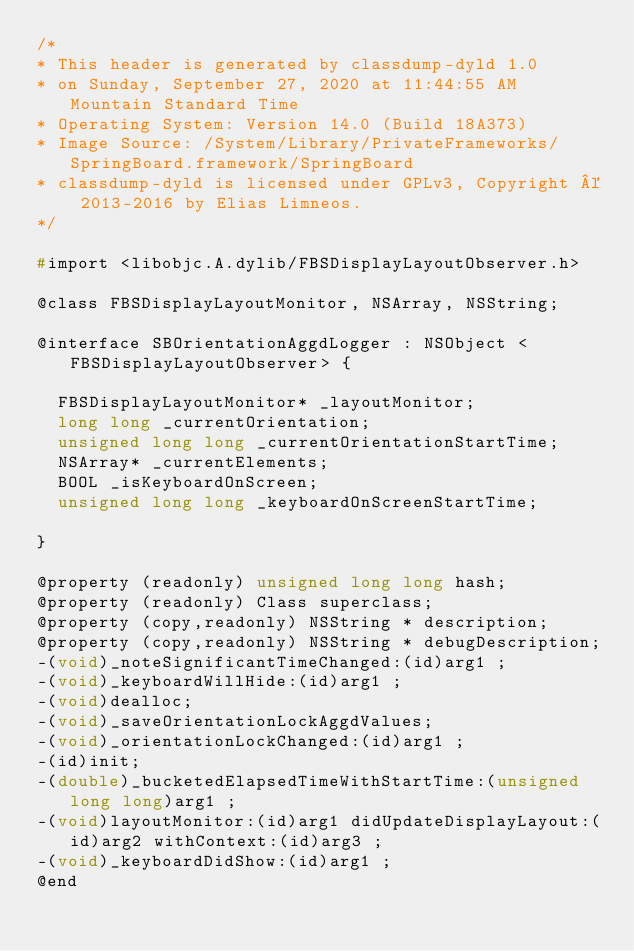<code> <loc_0><loc_0><loc_500><loc_500><_C_>/*
* This header is generated by classdump-dyld 1.0
* on Sunday, September 27, 2020 at 11:44:55 AM Mountain Standard Time
* Operating System: Version 14.0 (Build 18A373)
* Image Source: /System/Library/PrivateFrameworks/SpringBoard.framework/SpringBoard
* classdump-dyld is licensed under GPLv3, Copyright © 2013-2016 by Elias Limneos.
*/

#import <libobjc.A.dylib/FBSDisplayLayoutObserver.h>

@class FBSDisplayLayoutMonitor, NSArray, NSString;

@interface SBOrientationAggdLogger : NSObject <FBSDisplayLayoutObserver> {

	FBSDisplayLayoutMonitor* _layoutMonitor;
	long long _currentOrientation;
	unsigned long long _currentOrientationStartTime;
	NSArray* _currentElements;
	BOOL _isKeyboardOnScreen;
	unsigned long long _keyboardOnScreenStartTime;

}

@property (readonly) unsigned long long hash; 
@property (readonly) Class superclass; 
@property (copy,readonly) NSString * description; 
@property (copy,readonly) NSString * debugDescription; 
-(void)_noteSignificantTimeChanged:(id)arg1 ;
-(void)_keyboardWillHide:(id)arg1 ;
-(void)dealloc;
-(void)_saveOrientationLockAggdValues;
-(void)_orientationLockChanged:(id)arg1 ;
-(id)init;
-(double)_bucketedElapsedTimeWithStartTime:(unsigned long long)arg1 ;
-(void)layoutMonitor:(id)arg1 didUpdateDisplayLayout:(id)arg2 withContext:(id)arg3 ;
-(void)_keyboardDidShow:(id)arg1 ;
@end

</code> 